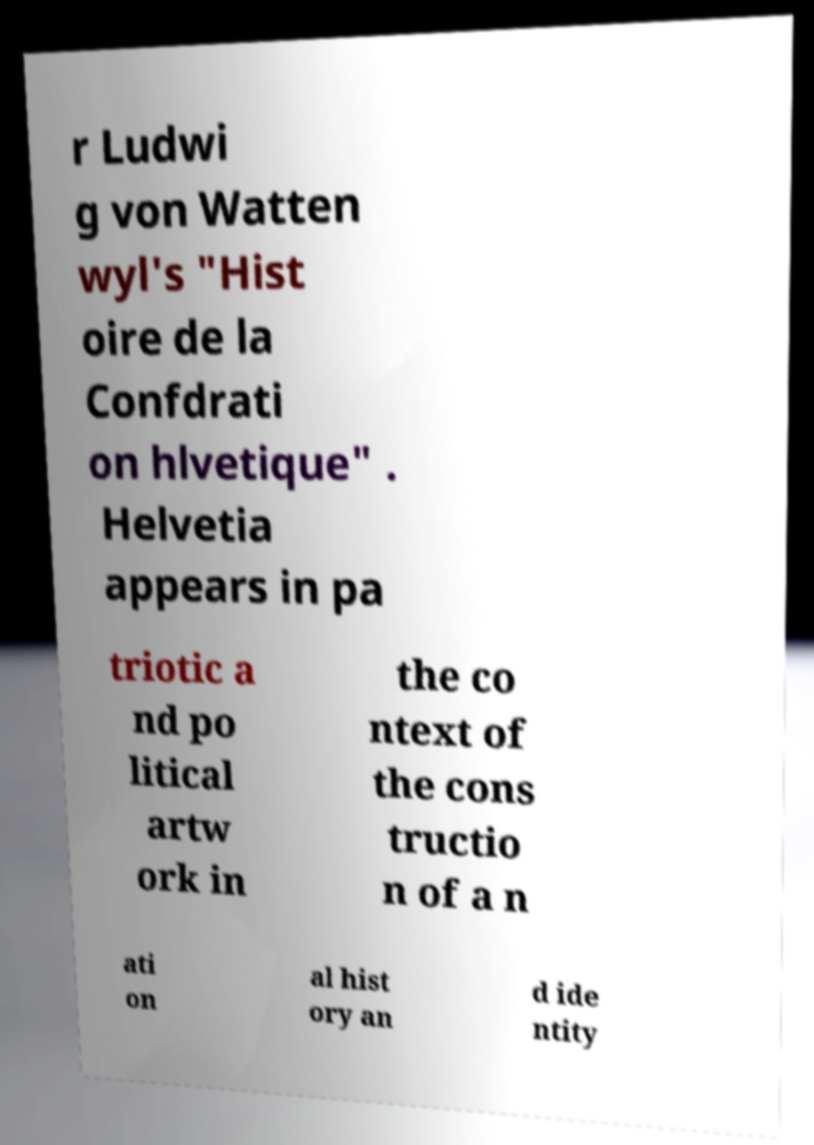Could you assist in decoding the text presented in this image and type it out clearly? r Ludwi g von Watten wyl's "Hist oire de la Confdrati on hlvetique" . Helvetia appears in pa triotic a nd po litical artw ork in the co ntext of the cons tructio n of a n ati on al hist ory an d ide ntity 